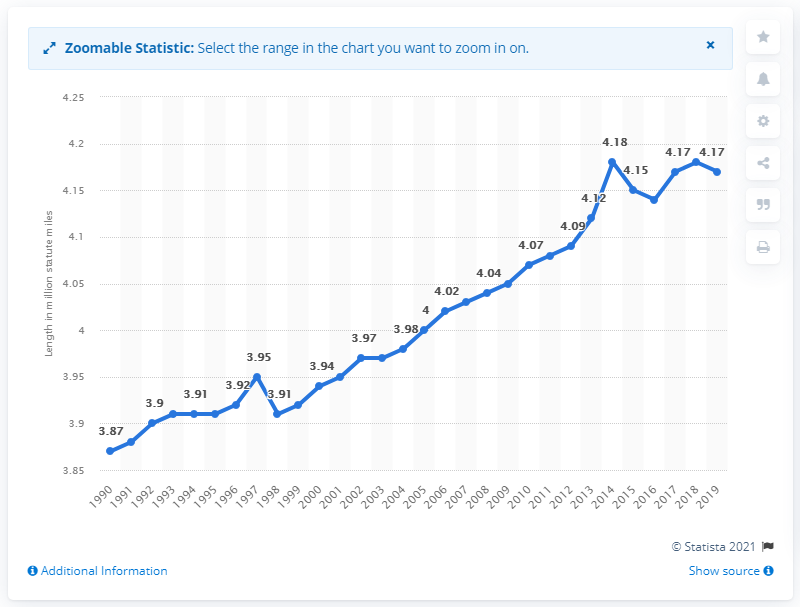List a handful of essential elements in this visual. In 2019, the total length of the highway network in the United States was 4.17 thousand miles. 